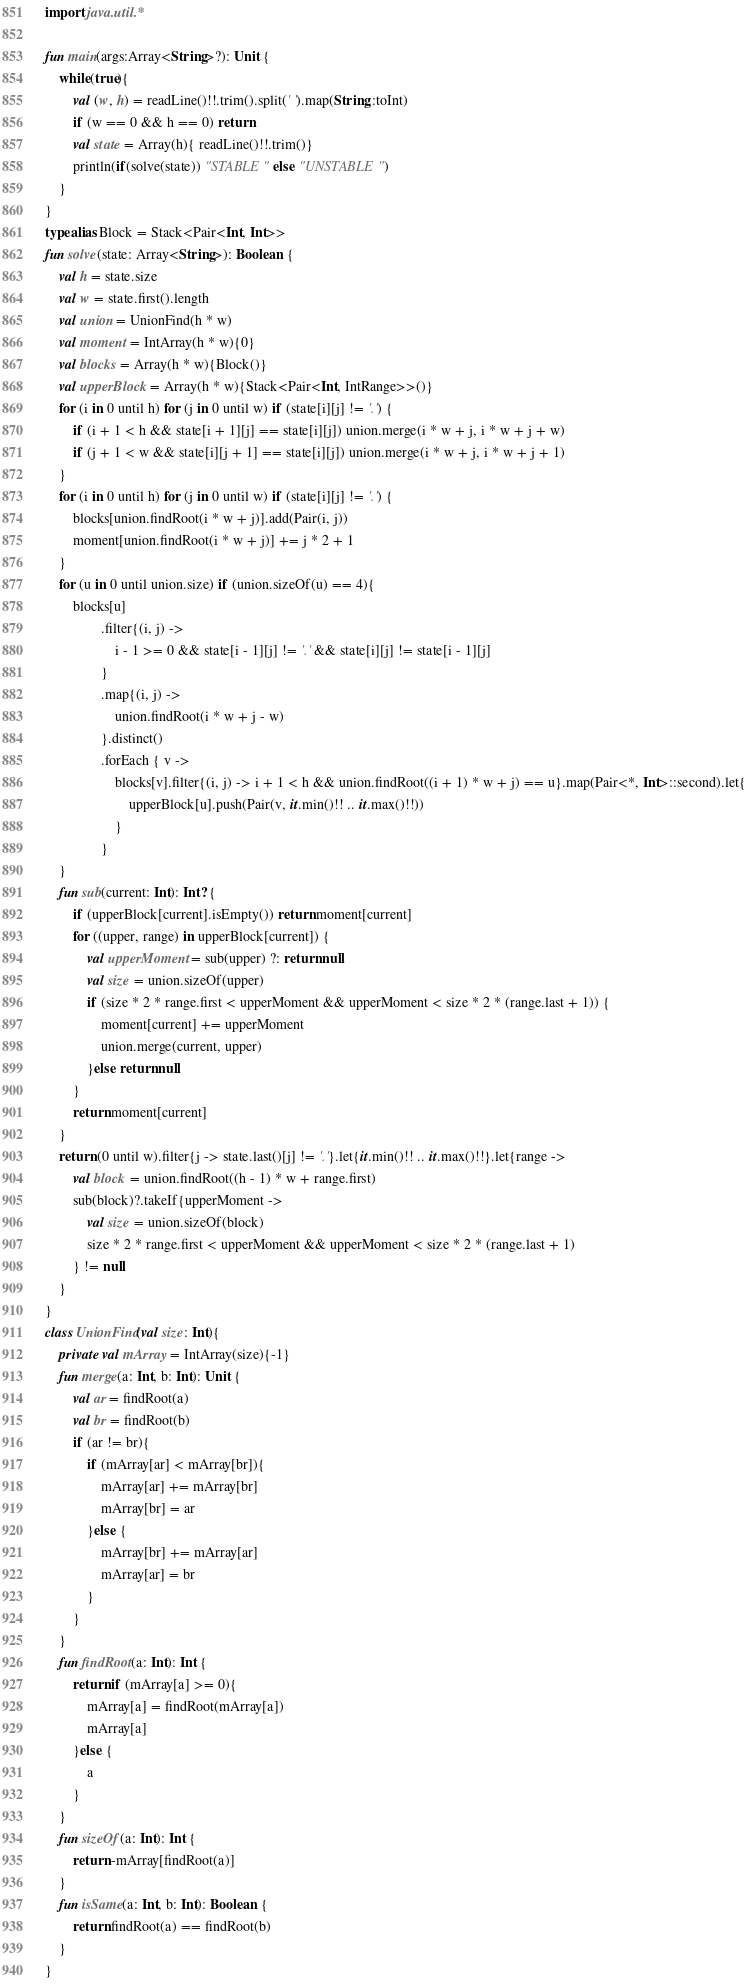<code> <loc_0><loc_0><loc_500><loc_500><_Kotlin_>import java.util.*

fun main(args:Array<String>?): Unit {
    while(true){
        val (w, h) = readLine()!!.trim().split(' ').map(String::toInt)
        if (w == 0 && h == 0) return
        val state = Array(h){ readLine()!!.trim()}
        println(if(solve(state)) "STABLE" else "UNSTABLE")
    }
}
typealias Block = Stack<Pair<Int, Int>>
fun solve(state: Array<String>): Boolean {
    val h = state.size
    val w = state.first().length
    val union = UnionFind(h * w)
    val moment = IntArray(h * w){0}
    val blocks = Array(h * w){Block()}
    val upperBlock = Array(h * w){Stack<Pair<Int, IntRange>>()}
    for (i in 0 until h) for (j in 0 until w) if (state[i][j] != '.') {
        if (i + 1 < h && state[i + 1][j] == state[i][j]) union.merge(i * w + j, i * w + j + w)
        if (j + 1 < w && state[i][j + 1] == state[i][j]) union.merge(i * w + j, i * w + j + 1)
    }
    for (i in 0 until h) for (j in 0 until w) if (state[i][j] != '.') {
        blocks[union.findRoot(i * w + j)].add(Pair(i, j))
        moment[union.findRoot(i * w + j)] += j * 2 + 1
    }
    for (u in 0 until union.size) if (union.sizeOf(u) == 4){
        blocks[u]
                .filter{(i, j) ->
                    i - 1 >= 0 && state[i - 1][j] != '.' && state[i][j] != state[i - 1][j]
                }
                .map{(i, j) ->
                    union.findRoot(i * w + j - w)
                }.distinct()
                .forEach { v ->
                    blocks[v].filter{(i, j) -> i + 1 < h && union.findRoot((i + 1) * w + j) == u}.map(Pair<*, Int>::second).let{
                        upperBlock[u].push(Pair(v, it.min()!! .. it.max()!!))
                    }
                }
    }
    fun sub(current: Int): Int? {
        if (upperBlock[current].isEmpty()) return moment[current]
        for ((upper, range) in upperBlock[current]) {
            val upperMoment = sub(upper) ?: return null
            val size = union.sizeOf(upper)
            if (size * 2 * range.first < upperMoment && upperMoment < size * 2 * (range.last + 1)) {
                moment[current] += upperMoment
                union.merge(current, upper)
            }else return null
        }
        return moment[current]
    }
    return (0 until w).filter{j -> state.last()[j] != '.'}.let{it.min()!! .. it.max()!!}.let{range ->
        val block = union.findRoot((h - 1) * w + range.first)
        sub(block)?.takeIf{upperMoment ->
            val size = union.sizeOf(block)
            size * 2 * range.first < upperMoment && upperMoment < size * 2 * (range.last + 1)
        } != null
    }
}
class UnionFind(val size: Int){
    private val mArray = IntArray(size){-1}
    fun merge(a: Int, b: Int): Unit {
        val ar = findRoot(a)
        val br = findRoot(b)
        if (ar != br){
            if (mArray[ar] < mArray[br]){
                mArray[ar] += mArray[br]
                mArray[br] = ar
            }else {
                mArray[br] += mArray[ar]
                mArray[ar] = br
            }
        }
    }
    fun findRoot(a: Int): Int {
        return if (mArray[a] >= 0){
            mArray[a] = findRoot(mArray[a])
            mArray[a]
        }else {
            a
        }
    }
    fun sizeOf(a: Int): Int {
        return -mArray[findRoot(a)]
    }
    fun isSame(a: Int, b: Int): Boolean {
        return findRoot(a) == findRoot(b)
    }
}
</code> 